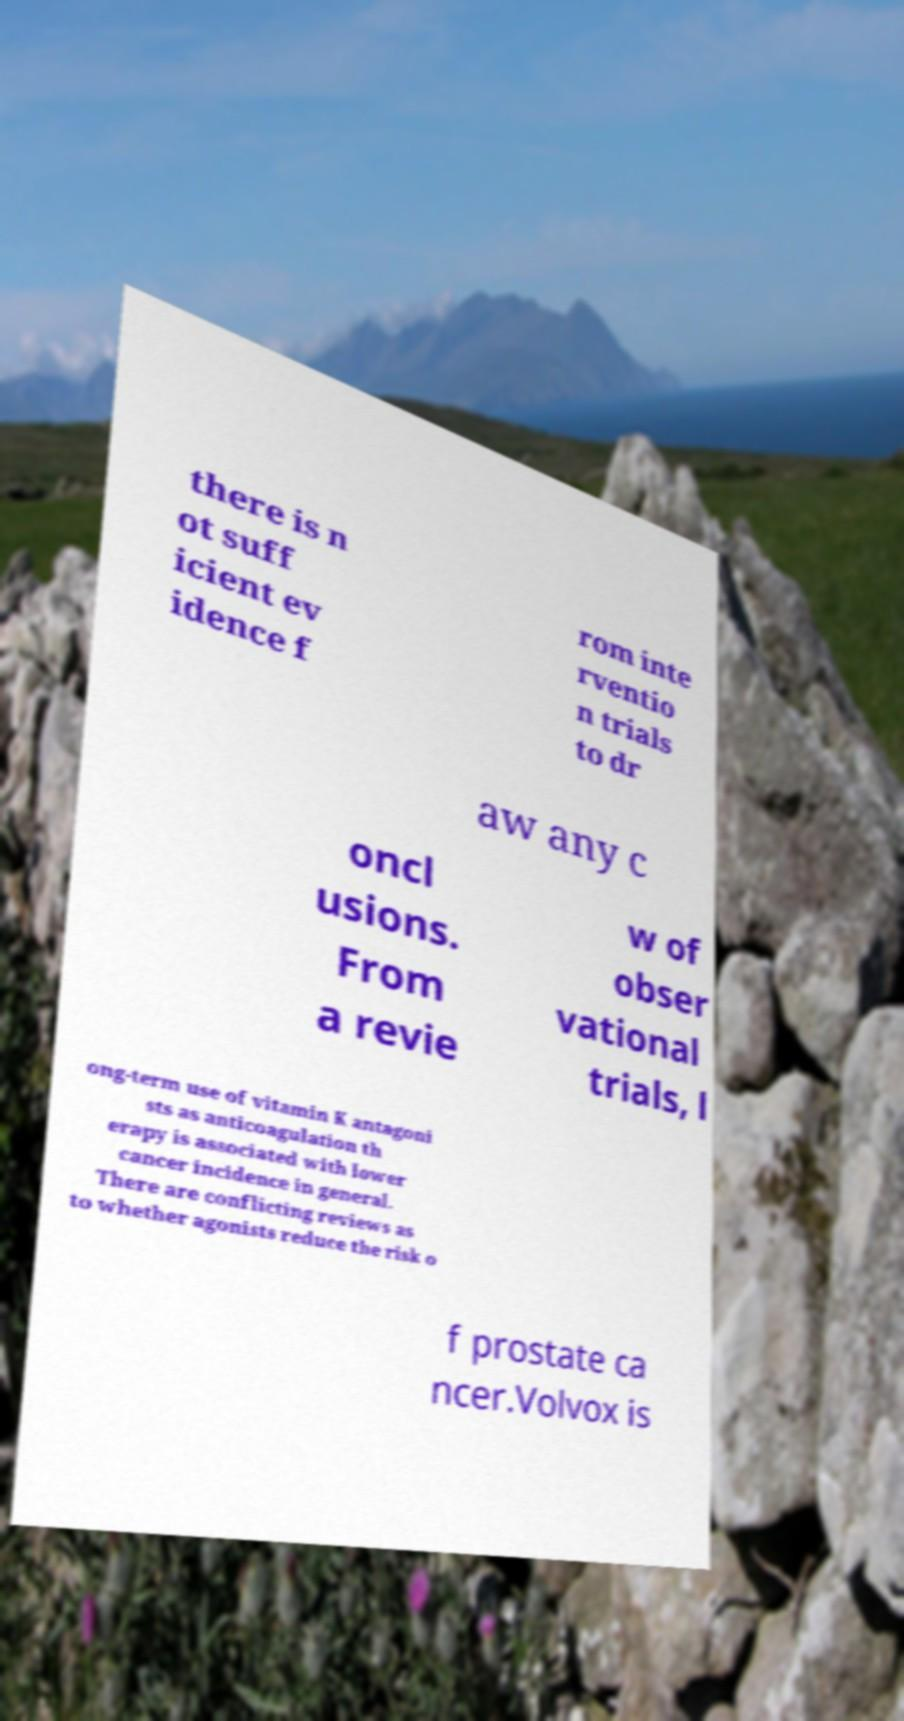Can you accurately transcribe the text from the provided image for me? there is n ot suff icient ev idence f rom inte rventio n trials to dr aw any c oncl usions. From a revie w of obser vational trials, l ong-term use of vitamin K antagoni sts as anticoagulation th erapy is associated with lower cancer incidence in general. There are conflicting reviews as to whether agonists reduce the risk o f prostate ca ncer.Volvox is 